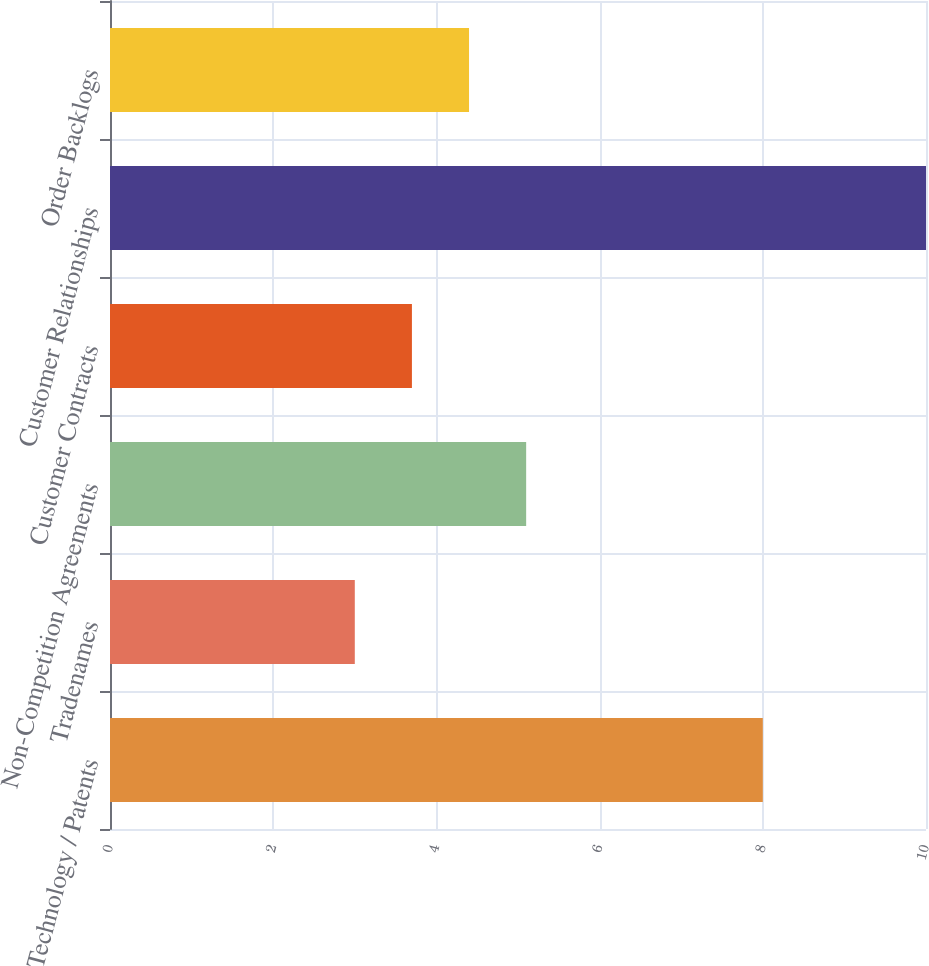<chart> <loc_0><loc_0><loc_500><loc_500><bar_chart><fcel>Technology / Patents<fcel>Tradenames<fcel>Non-Competition Agreements<fcel>Customer Contracts<fcel>Customer Relationships<fcel>Order Backlogs<nl><fcel>8<fcel>3<fcel>5.1<fcel>3.7<fcel>10<fcel>4.4<nl></chart> 